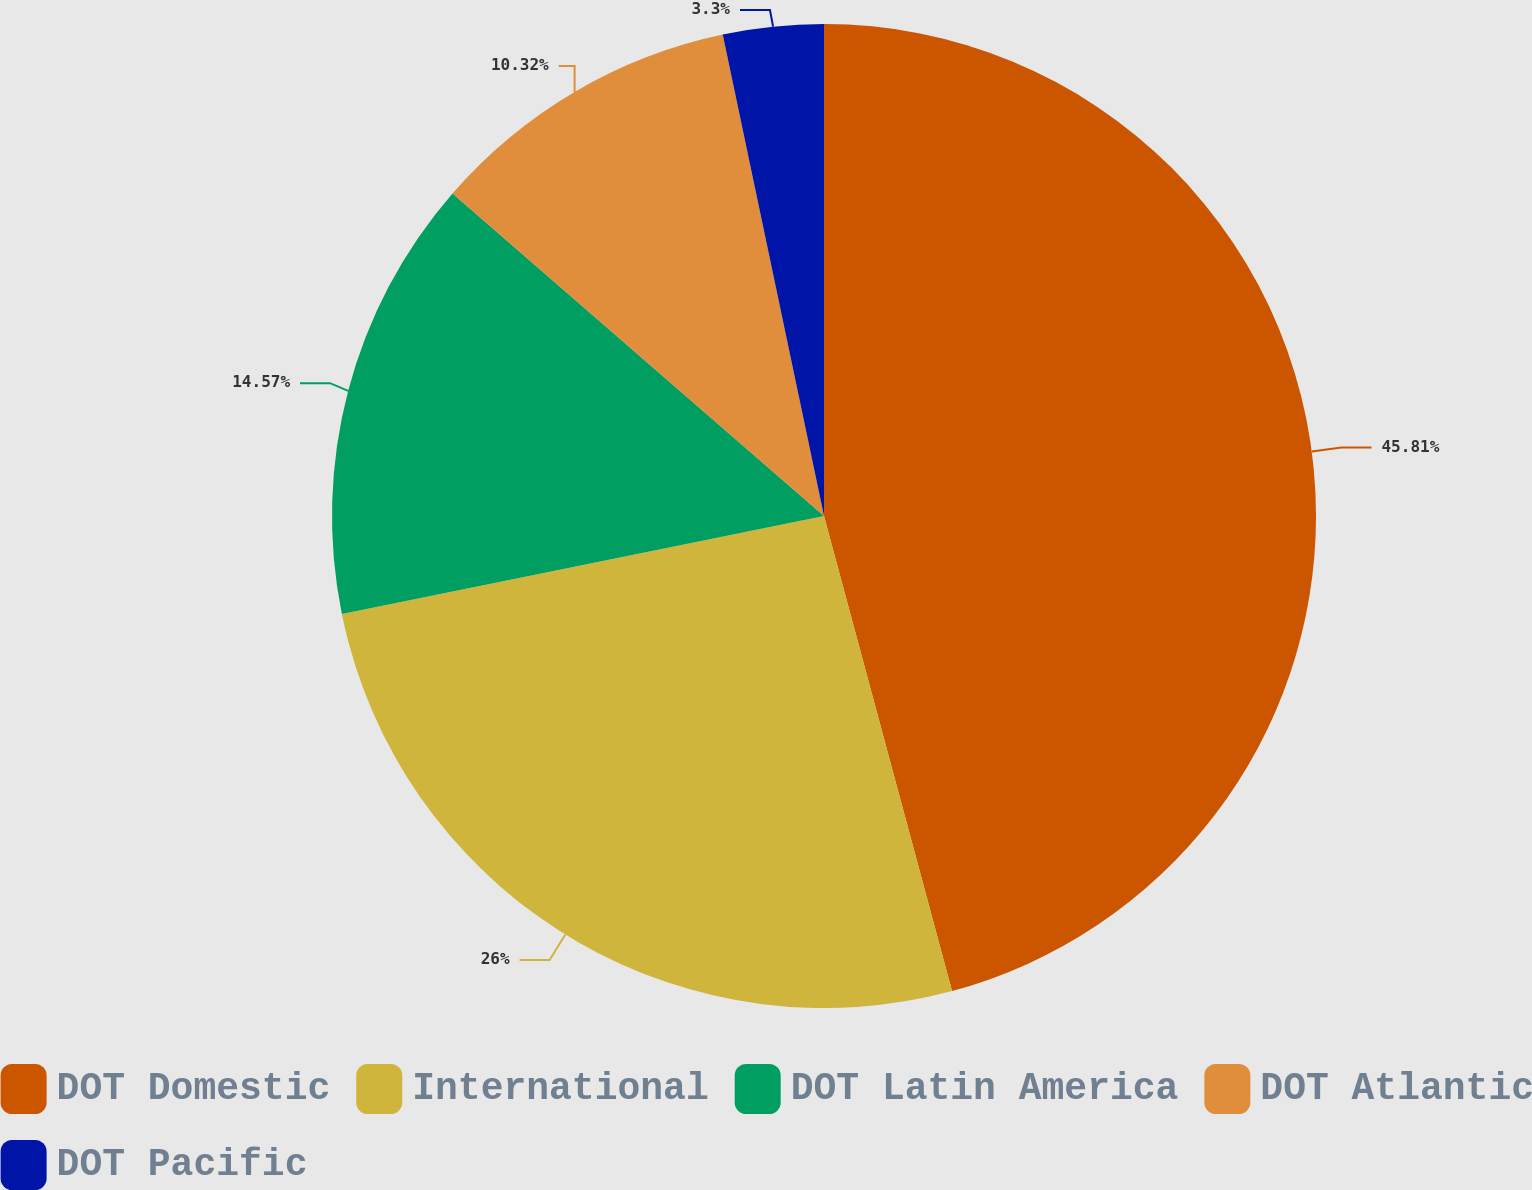<chart> <loc_0><loc_0><loc_500><loc_500><pie_chart><fcel>DOT Domestic<fcel>International<fcel>DOT Latin America<fcel>DOT Atlantic<fcel>DOT Pacific<nl><fcel>45.81%<fcel>26.0%<fcel>14.57%<fcel>10.32%<fcel>3.3%<nl></chart> 